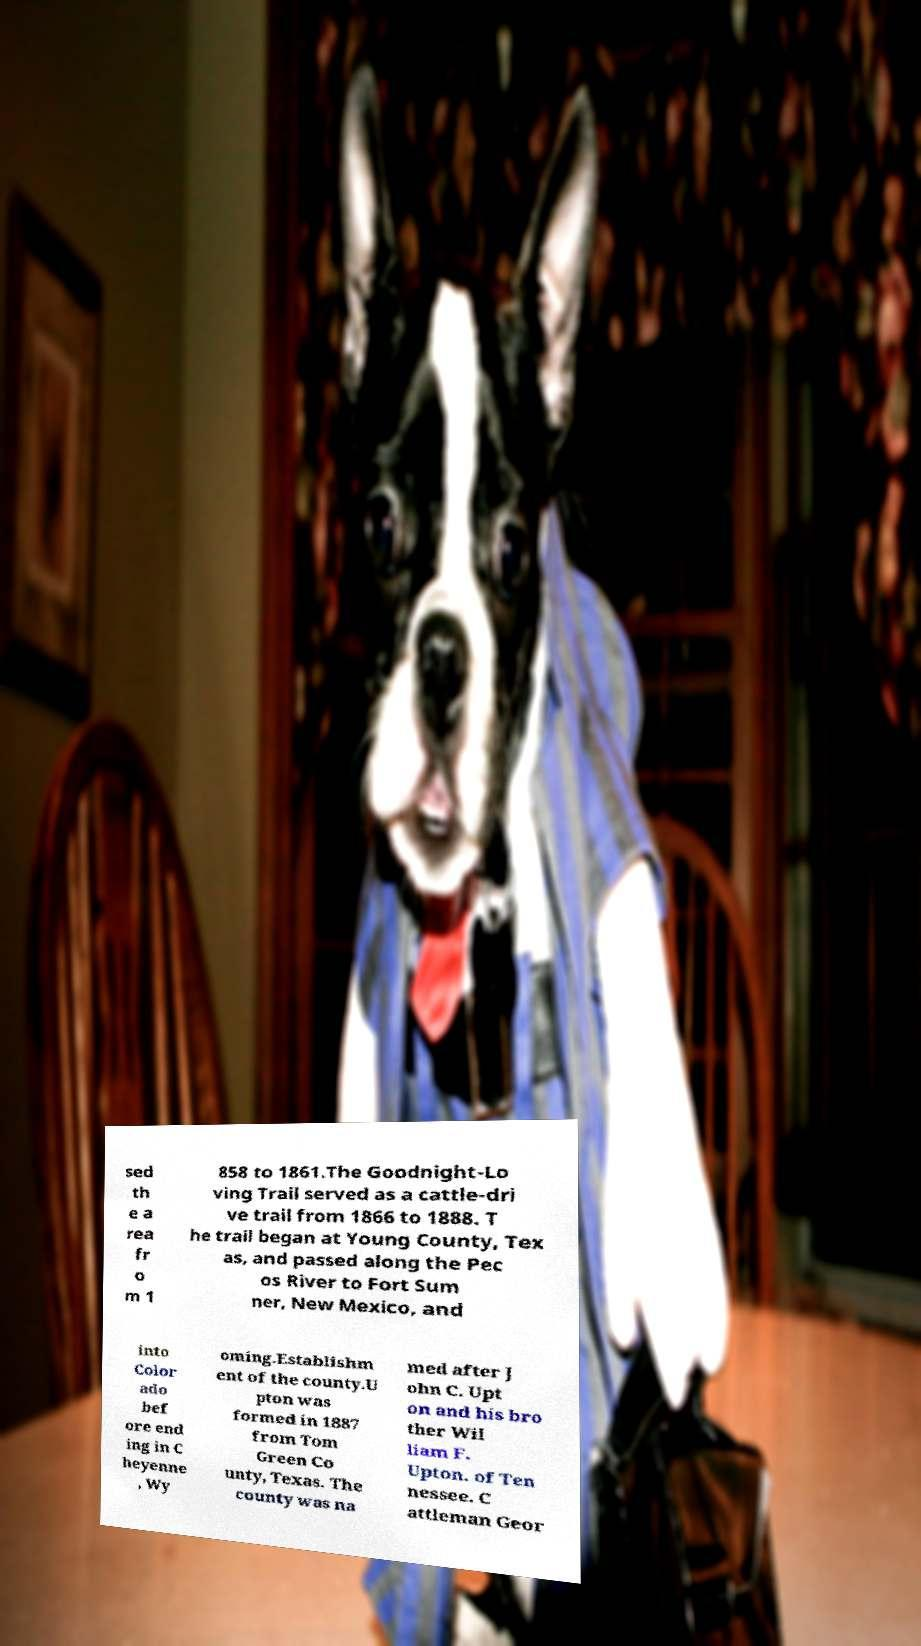Can you read and provide the text displayed in the image?This photo seems to have some interesting text. Can you extract and type it out for me? sed th e a rea fr o m 1 858 to 1861.The Goodnight-Lo ving Trail served as a cattle-dri ve trail from 1866 to 1888. T he trail began at Young County, Tex as, and passed along the Pec os River to Fort Sum ner, New Mexico, and into Color ado bef ore end ing in C heyenne , Wy oming.Establishm ent of the county.U pton was formed in 1887 from Tom Green Co unty, Texas. The county was na med after J ohn C. Upt on and his bro ther Wil liam F. Upton. of Ten nessee. C attleman Geor 